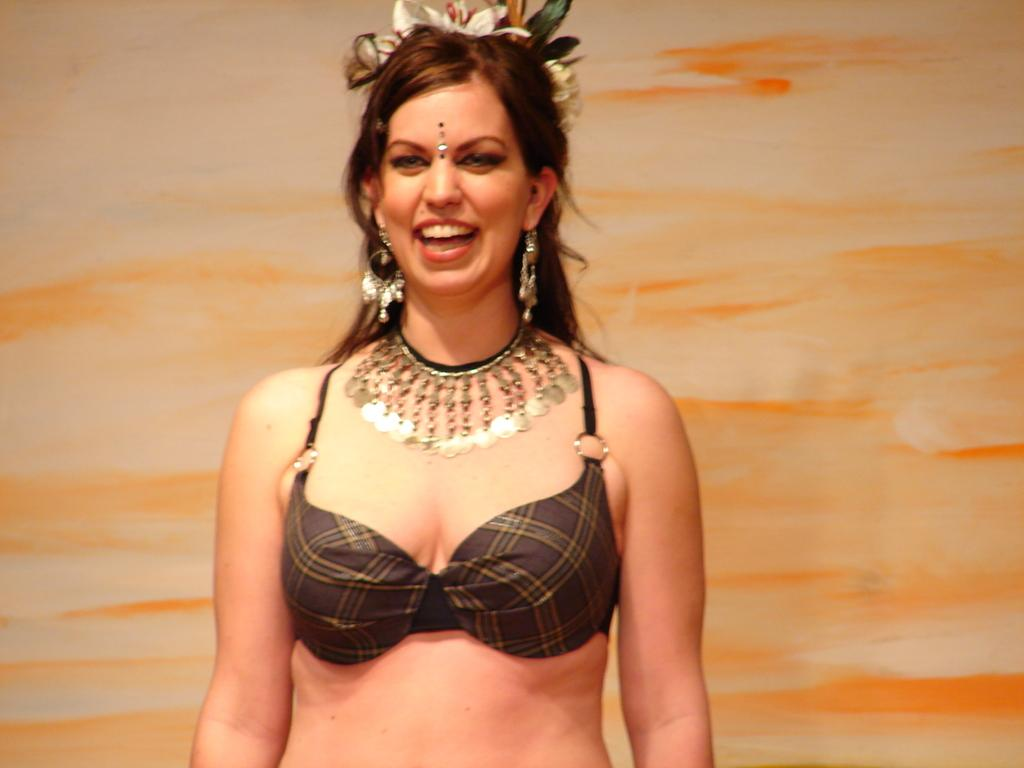Who is the main subject in the image? There is a lady in the center of the image. What is the lady doing in the image? The lady is standing and laughing. What can be seen in the background of the image? There is a wall visible in the background of the image. What type of meal is being prepared in the image? There is no meal preparation visible in the image; it features a lady standing and laughing. How many roses can be seen in the image? There are no roses present in the image. 